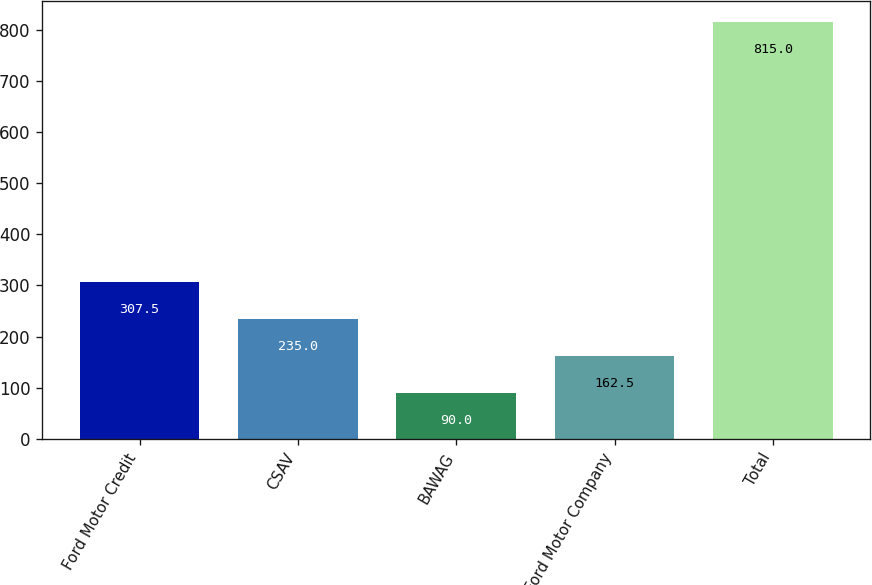Convert chart to OTSL. <chart><loc_0><loc_0><loc_500><loc_500><bar_chart><fcel>Ford Motor Credit<fcel>CSAV<fcel>BAWAG<fcel>Ford Motor Company<fcel>Total<nl><fcel>307.5<fcel>235<fcel>90<fcel>162.5<fcel>815<nl></chart> 